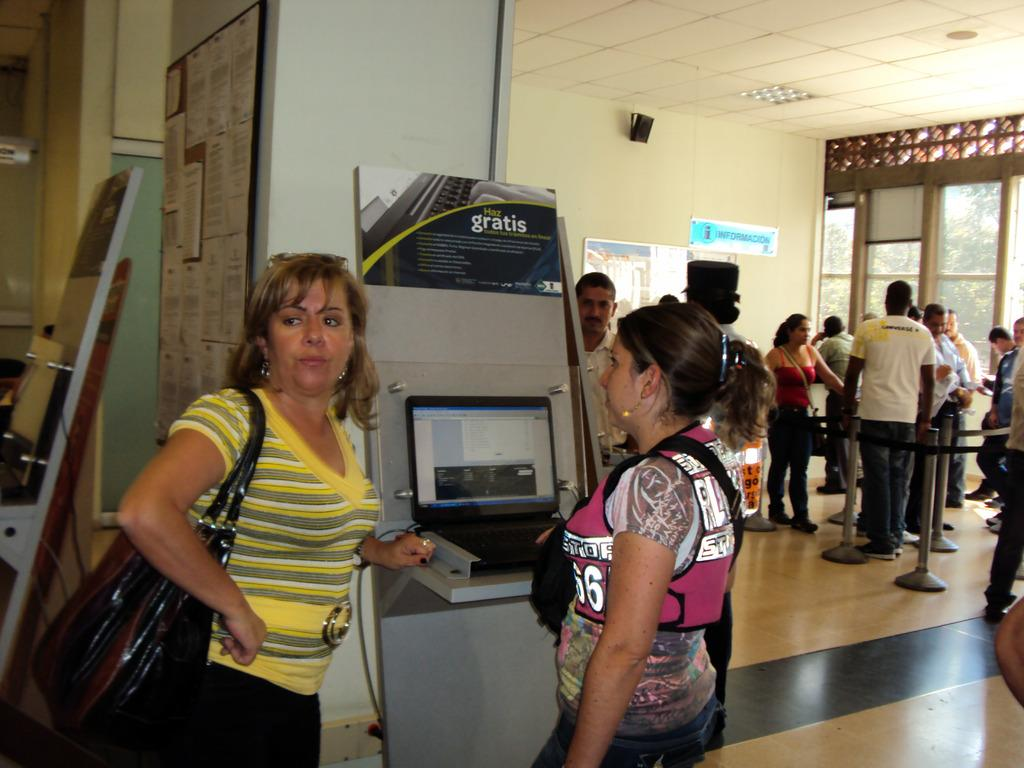<image>
Create a compact narrative representing the image presented. Two women stand by a booth that says Haz gratis. 